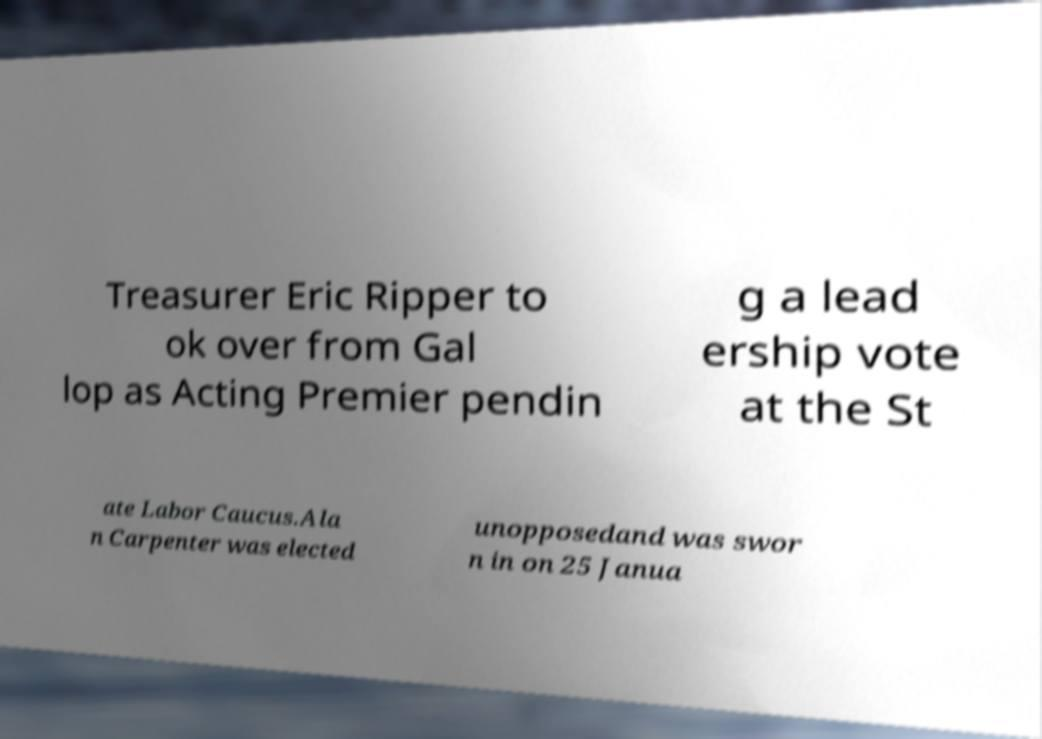Please read and relay the text visible in this image. What does it say? Treasurer Eric Ripper to ok over from Gal lop as Acting Premier pendin g a lead ership vote at the St ate Labor Caucus.Ala n Carpenter was elected unopposedand was swor n in on 25 Janua 